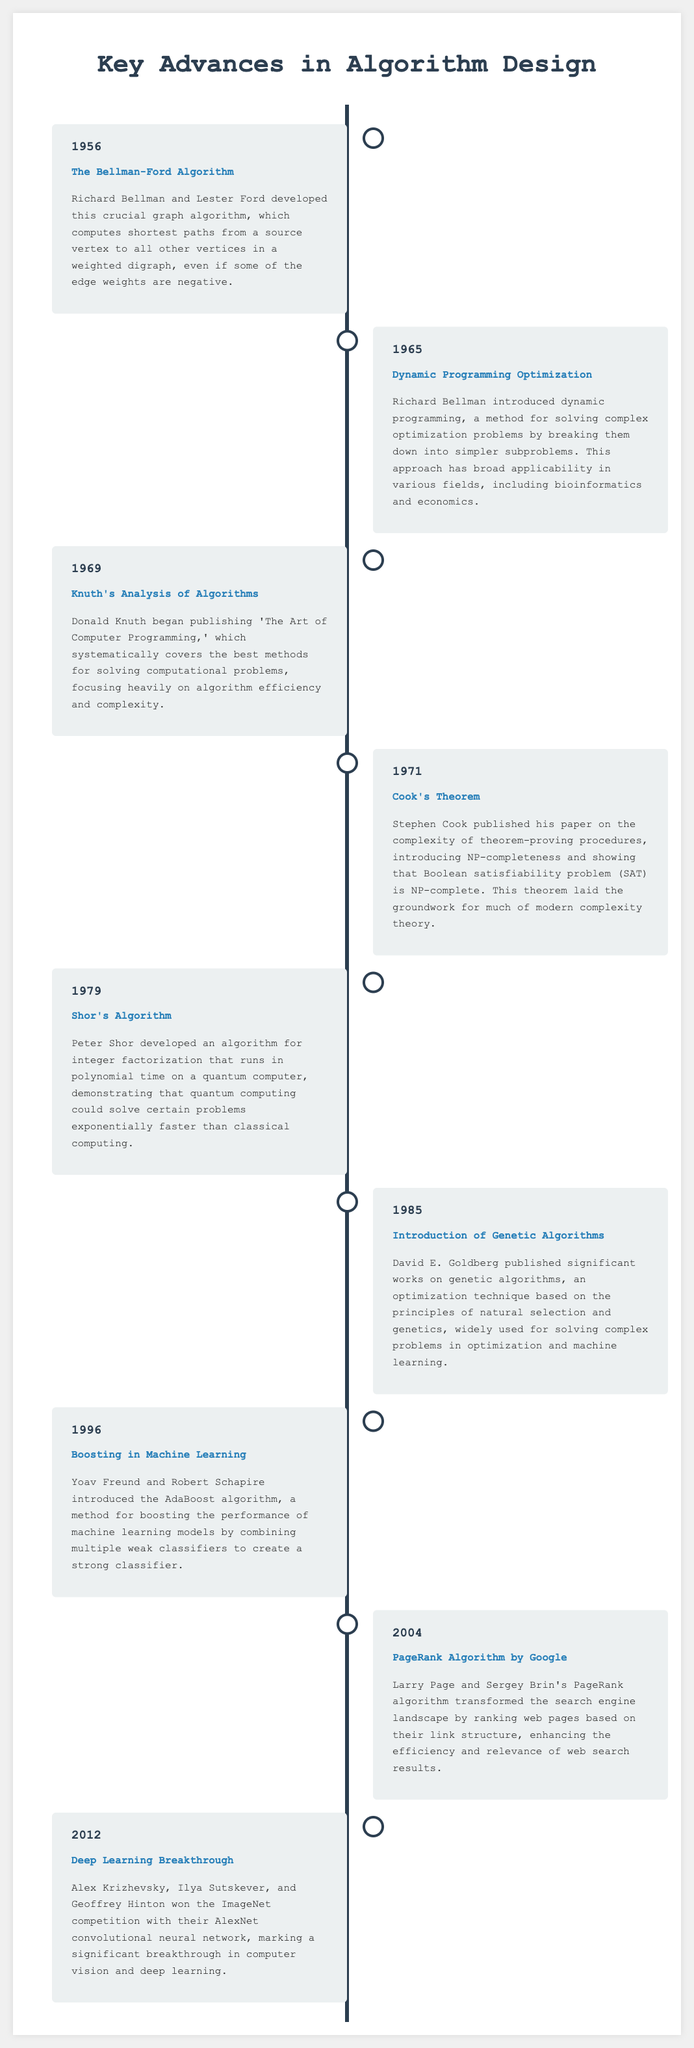what was introduced in 1956? The document states that the Bellman-Ford Algorithm was developed in 1956.
Answer: Bellman-Ford Algorithm who developed Shor's Algorithm? The timeline notes that Shor's Algorithm was developed by Peter Shor.
Answer: Peter Shor which algorithm is associated with NP-completeness? According to the entry from 1971, Cook's Theorem introduced NP-completeness.
Answer: Cook's Theorem what year was the deep learning breakthrough? The document states that the deep learning breakthrough occurred in 2012.
Answer: 2012 who are the authors of the AdaBoost algorithm? The timeline indicates that Yoav Freund and Robert Schapire introduced the AdaBoost algorithm.
Answer: Yoav Freund and Robert Schapire in what field did dynamic programming find broad applicability? The entry for Dynamic Programming Optimization mentions its applicability in various fields, including bioinformatics and economics.
Answer: bioinformatics and economics which algorithm transformed the search engine landscape? The timeline highlights that Google's PageRank algorithm transformed the search engine landscape.
Answer: PageRank Algorithm what technique is based on natural selection? The document mentions that genetic algorithms are based on the principles of natural selection.
Answer: genetic algorithms which publication focused heavily on algorithm efficiency? The timeline shows that 'The Art of Computer Programming' focused heavily on algorithm efficiency.
Answer: The Art of Computer Programming 